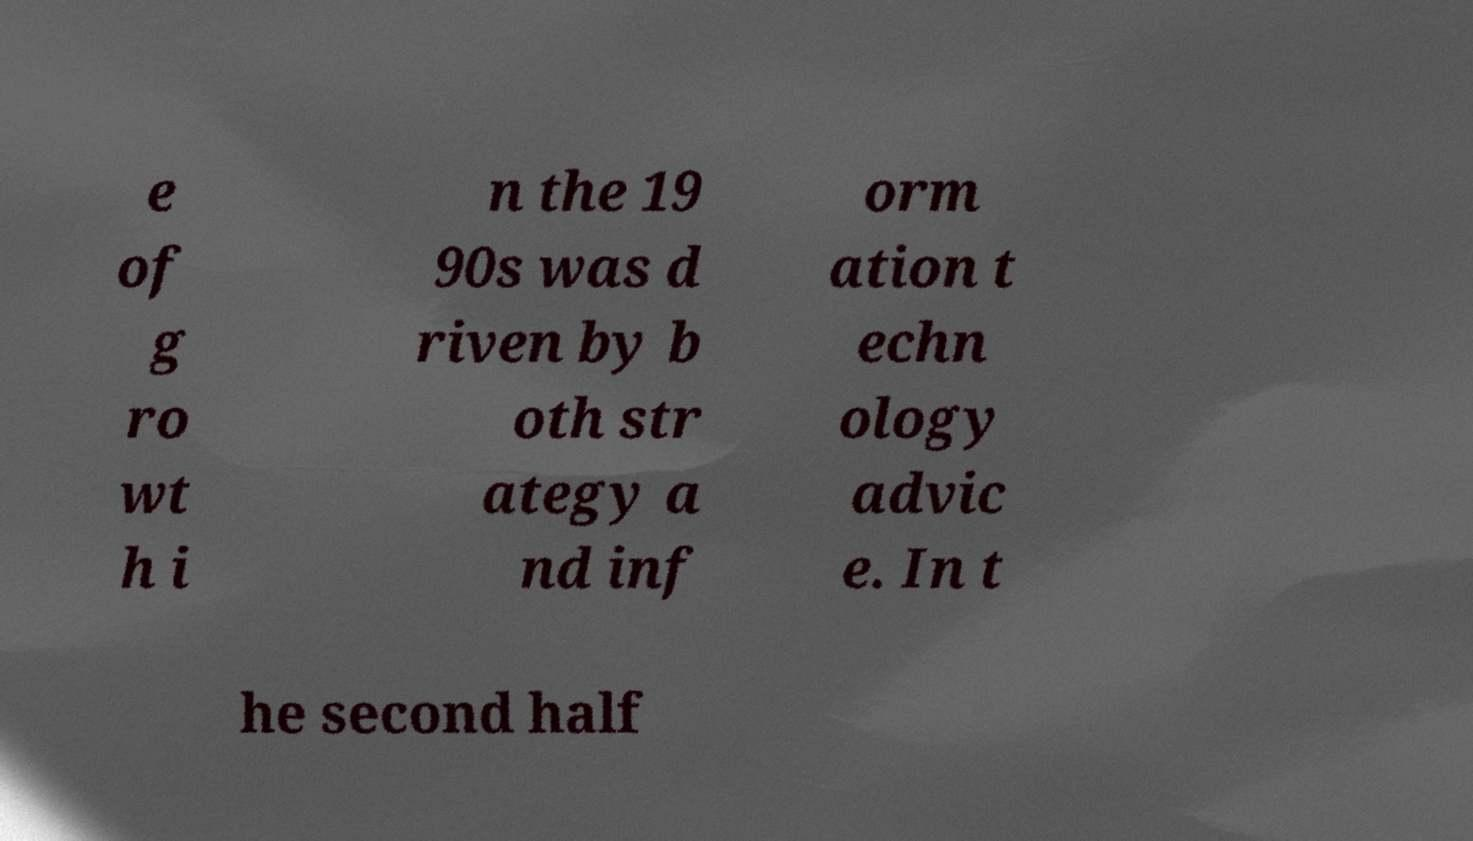Can you accurately transcribe the text from the provided image for me? e of g ro wt h i n the 19 90s was d riven by b oth str ategy a nd inf orm ation t echn ology advic e. In t he second half 